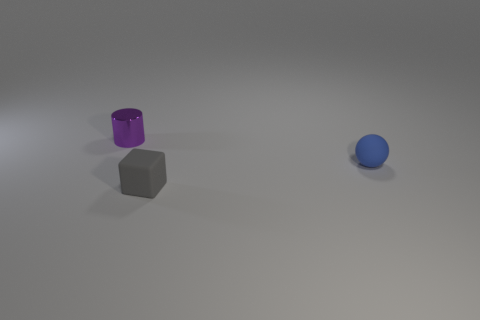There is a tiny thing on the right side of the rubber thing on the left side of the object to the right of the tiny gray object; what is its material?
Ensure brevity in your answer.  Rubber. How many other objects are there of the same size as the blue rubber object?
Keep it short and to the point. 2. What color is the rubber sphere?
Give a very brief answer. Blue. What color is the tiny thing behind the blue ball to the right of the cube?
Offer a very short reply. Purple. Is the color of the sphere the same as the thing that is on the left side of the tiny gray thing?
Give a very brief answer. No. How many things are behind the small matte thing behind the thing in front of the rubber ball?
Your response must be concise. 1. There is a gray thing; are there any tiny cubes behind it?
Provide a short and direct response. No. Is there any other thing that has the same color as the matte block?
Offer a terse response. No. What number of cylinders are tiny brown objects or purple things?
Make the answer very short. 1. How many small things are both to the left of the tiny matte cube and in front of the cylinder?
Provide a succinct answer. 0. 